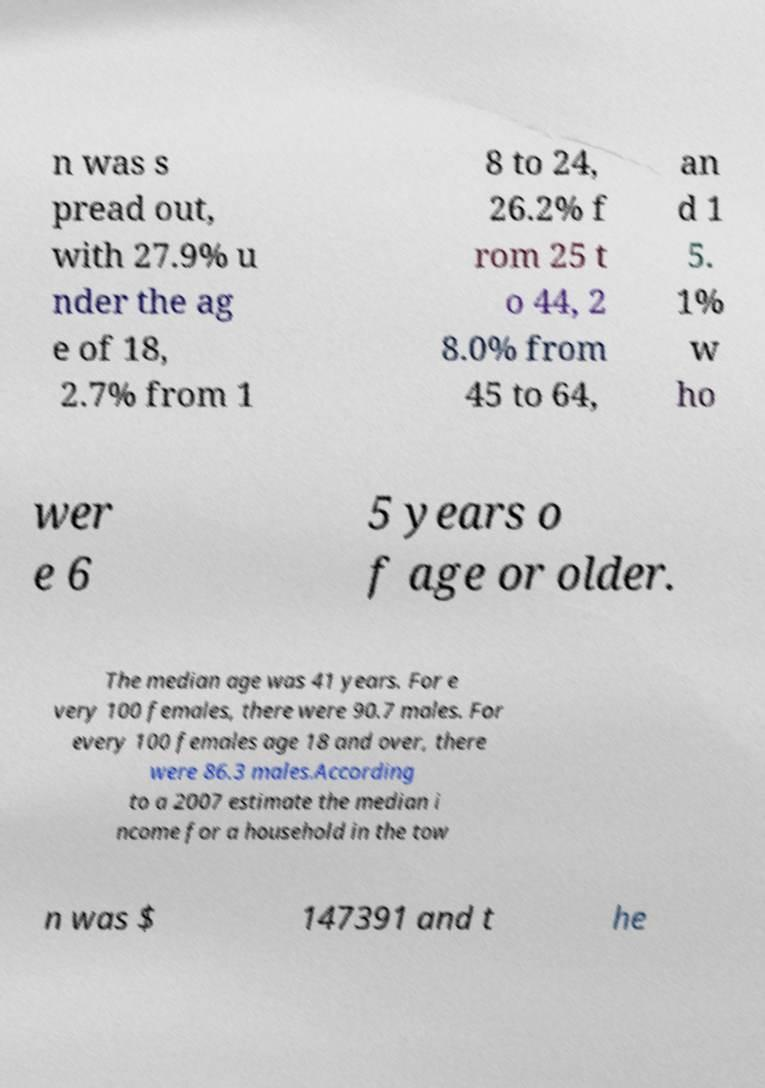Can you accurately transcribe the text from the provided image for me? n was s pread out, with 27.9% u nder the ag e of 18, 2.7% from 1 8 to 24, 26.2% f rom 25 t o 44, 2 8.0% from 45 to 64, an d 1 5. 1% w ho wer e 6 5 years o f age or older. The median age was 41 years. For e very 100 females, there were 90.7 males. For every 100 females age 18 and over, there were 86.3 males.According to a 2007 estimate the median i ncome for a household in the tow n was $ 147391 and t he 